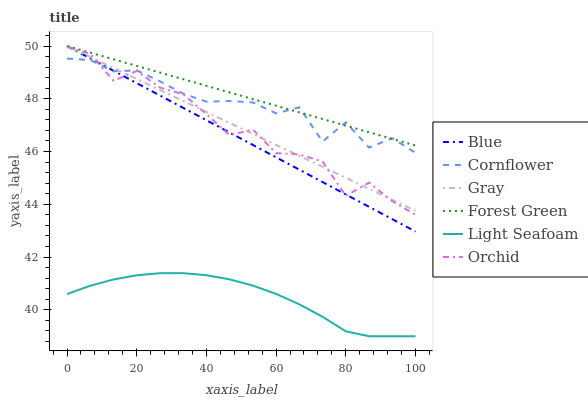Does Cornflower have the minimum area under the curve?
Answer yes or no. No. Does Cornflower have the maximum area under the curve?
Answer yes or no. No. Is Cornflower the smoothest?
Answer yes or no. No. Is Cornflower the roughest?
Answer yes or no. No. Does Cornflower have the lowest value?
Answer yes or no. No. Does Cornflower have the highest value?
Answer yes or no. No. Is Light Seafoam less than Blue?
Answer yes or no. Yes. Is Forest Green greater than Light Seafoam?
Answer yes or no. Yes. Does Light Seafoam intersect Blue?
Answer yes or no. No. 